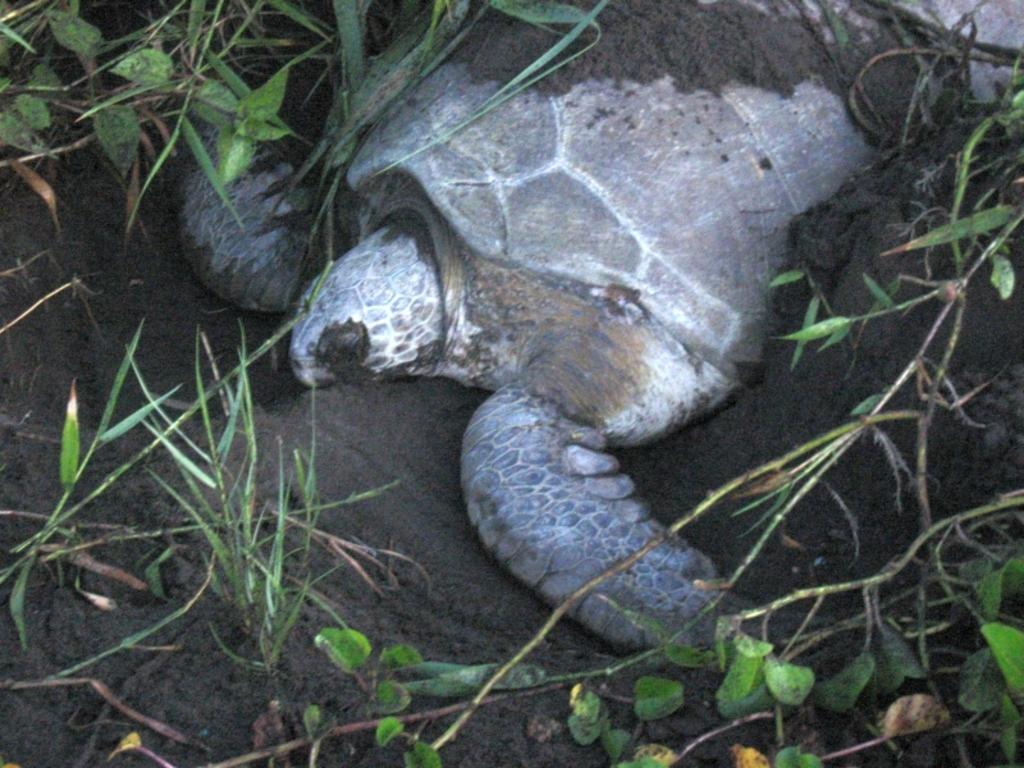What type of animal is in the image? There is a tortoise in the image. What colors can be seen on the tortoise? The tortoise is brown and grey in color. What type of terrain is visible in the image? There is mud and grass visible in the image. How many friends does the tortoise have in the image? There is no information about friends in the image, as it only features the tortoise and the terrain. 